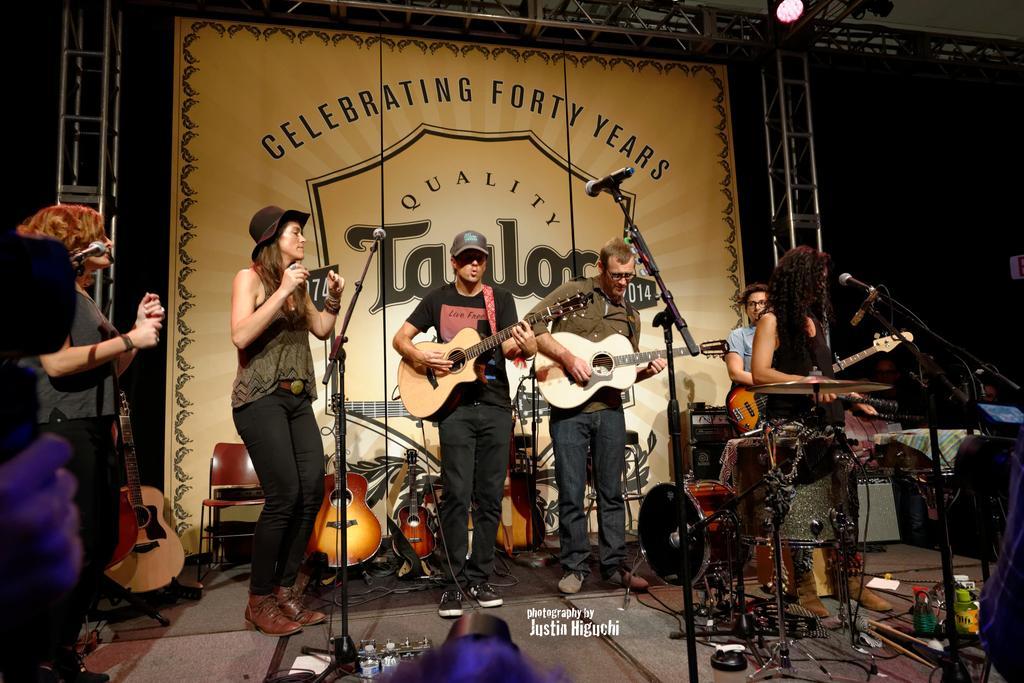Describe this image in one or two sentences. This picture is clicked in a musical concert. Here, we see many people in this concert. Two men and two women are are holding guitar in their hands and playing it. In the right corner of the picture, we see woman playing drums and woman in green shirt and black jeans wearing black cap is dancing. In front of them, we see microphone and on background, we see a wallpaper on which celebrating forty years is written on it. 